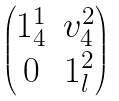<formula> <loc_0><loc_0><loc_500><loc_500>\begin{pmatrix} 1 ^ { 1 } _ { 4 } & v ^ { 2 } _ { 4 } \\ 0 & 1 ^ { 2 } _ { l } \end{pmatrix}</formula> 